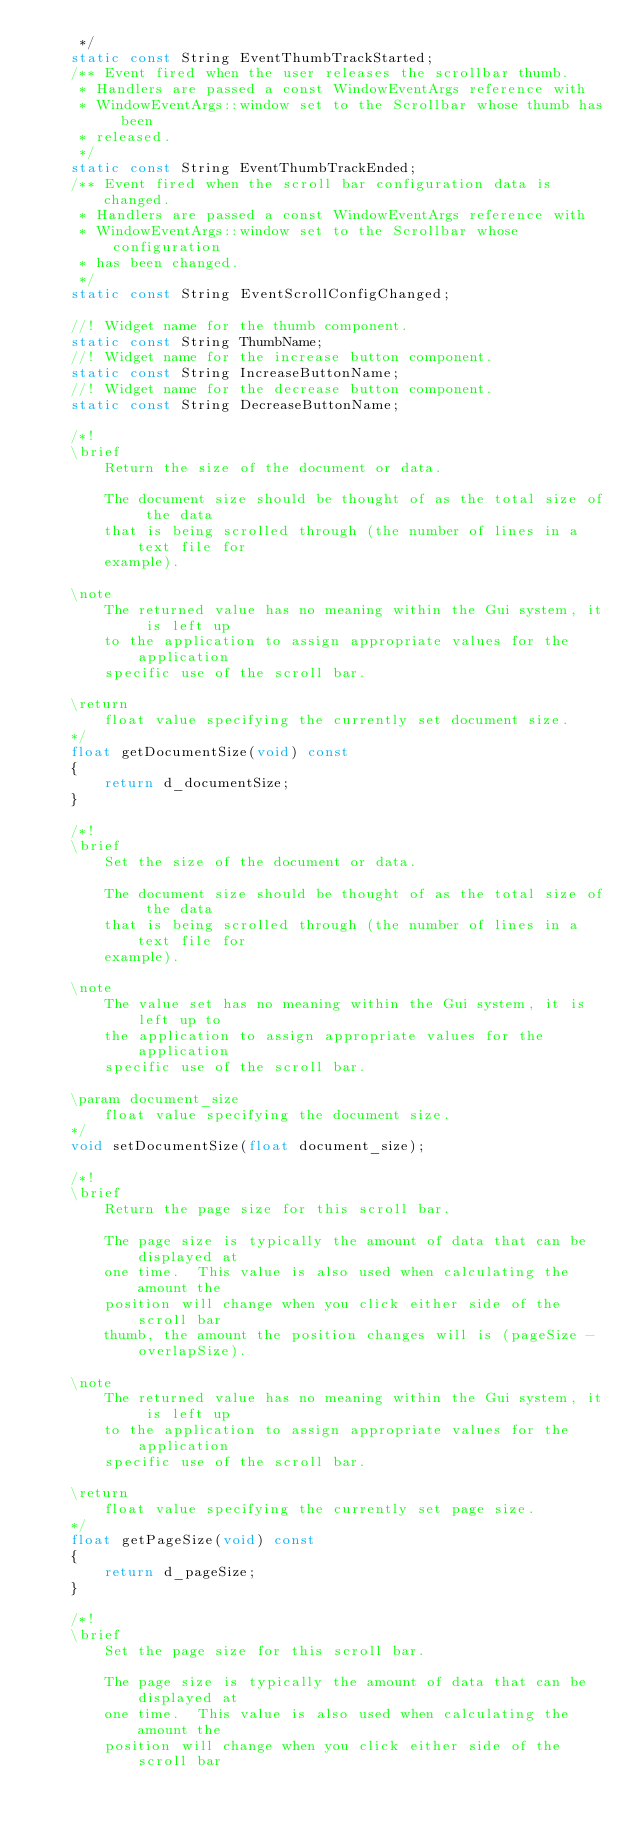Convert code to text. <code><loc_0><loc_0><loc_500><loc_500><_C_>     */
    static const String EventThumbTrackStarted;
    /** Event fired when the user releases the scrollbar thumb.
     * Handlers are passed a const WindowEventArgs reference with
     * WindowEventArgs::window set to the Scrollbar whose thumb has been
     * released.
     */
    static const String EventThumbTrackEnded;
    /** Event fired when the scroll bar configuration data is changed.
     * Handlers are passed a const WindowEventArgs reference with
     * WindowEventArgs::window set to the Scrollbar whose configuration
     * has been changed.
     */
    static const String EventScrollConfigChanged;

    //! Widget name for the thumb component.
    static const String ThumbName;
    //! Widget name for the increase button component.
    static const String IncreaseButtonName;
    //! Widget name for the decrease button component.
    static const String DecreaseButtonName;

    /*!
    \brief
        Return the size of the document or data.

        The document size should be thought of as the total size of the data
        that is being scrolled through (the number of lines in a text file for
        example).

    \note
        The returned value has no meaning within the Gui system, it is left up
        to the application to assign appropriate values for the application
        specific use of the scroll bar.

    \return
        float value specifying the currently set document size.
    */
    float getDocumentSize(void) const
    {
        return d_documentSize;
    }

    /*!
    \brief
        Set the size of the document or data.

        The document size should be thought of as the total size of the data
        that is being scrolled through (the number of lines in a text file for
        example).

    \note
        The value set has no meaning within the Gui system, it is left up to
        the application to assign appropriate values for the application
        specific use of the scroll bar.

    \param document_size
        float value specifying the document size.
    */
    void setDocumentSize(float document_size);

    /*!
    \brief
        Return the page size for this scroll bar.

        The page size is typically the amount of data that can be displayed at
        one time.  This value is also used when calculating the amount the
        position will change when you click either side of the scroll bar
        thumb, the amount the position changes will is (pageSize - overlapSize).

    \note
        The returned value has no meaning within the Gui system, it is left up
        to the application to assign appropriate values for the application
        specific use of the scroll bar.

    \return
        float value specifying the currently set page size.
    */
    float getPageSize(void) const
    {
        return d_pageSize;
    }

    /*!
    \brief
        Set the page size for this scroll bar.

        The page size is typically the amount of data that can be displayed at
        one time.  This value is also used when calculating the amount the
        position will change when you click either side of the scroll bar</code> 